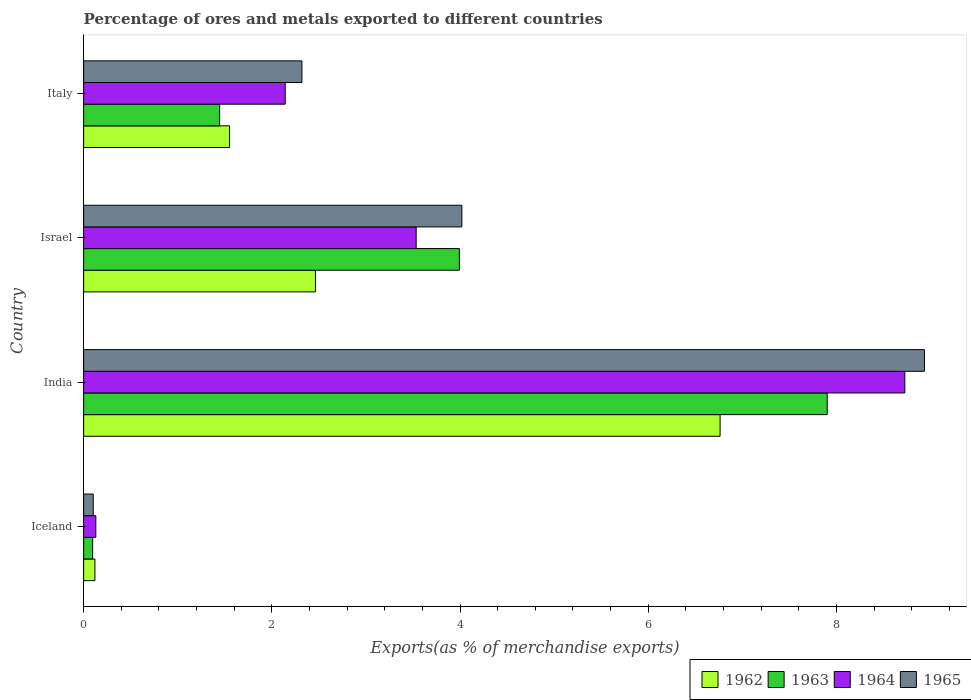How many groups of bars are there?
Your answer should be very brief. 4. Are the number of bars on each tick of the Y-axis equal?
Your response must be concise. Yes. How many bars are there on the 2nd tick from the bottom?
Your answer should be very brief. 4. What is the percentage of exports to different countries in 1963 in India?
Your answer should be compact. 7.9. Across all countries, what is the maximum percentage of exports to different countries in 1964?
Provide a succinct answer. 8.73. Across all countries, what is the minimum percentage of exports to different countries in 1963?
Ensure brevity in your answer.  0.1. In which country was the percentage of exports to different countries in 1965 maximum?
Offer a terse response. India. In which country was the percentage of exports to different countries in 1962 minimum?
Provide a succinct answer. Iceland. What is the total percentage of exports to different countries in 1964 in the graph?
Ensure brevity in your answer.  14.53. What is the difference between the percentage of exports to different countries in 1962 in Iceland and that in India?
Offer a very short reply. -6.64. What is the difference between the percentage of exports to different countries in 1964 in Iceland and the percentage of exports to different countries in 1963 in Israel?
Your answer should be compact. -3.86. What is the average percentage of exports to different countries in 1964 per country?
Offer a very short reply. 3.63. What is the difference between the percentage of exports to different countries in 1962 and percentage of exports to different countries in 1964 in India?
Offer a very short reply. -1.96. In how many countries, is the percentage of exports to different countries in 1965 greater than 4 %?
Ensure brevity in your answer.  2. What is the ratio of the percentage of exports to different countries in 1965 in Iceland to that in Israel?
Provide a succinct answer. 0.03. Is the percentage of exports to different countries in 1964 in Iceland less than that in India?
Provide a short and direct response. Yes. Is the difference between the percentage of exports to different countries in 1962 in India and Italy greater than the difference between the percentage of exports to different countries in 1964 in India and Italy?
Offer a terse response. No. What is the difference between the highest and the second highest percentage of exports to different countries in 1964?
Give a very brief answer. 5.19. What is the difference between the highest and the lowest percentage of exports to different countries in 1963?
Provide a succinct answer. 7.81. In how many countries, is the percentage of exports to different countries in 1963 greater than the average percentage of exports to different countries in 1963 taken over all countries?
Keep it short and to the point. 2. What does the 1st bar from the top in India represents?
Give a very brief answer. 1965. Are all the bars in the graph horizontal?
Make the answer very short. Yes. Are the values on the major ticks of X-axis written in scientific E-notation?
Your response must be concise. No. Does the graph contain grids?
Your answer should be very brief. No. How are the legend labels stacked?
Make the answer very short. Horizontal. What is the title of the graph?
Provide a short and direct response. Percentage of ores and metals exported to different countries. What is the label or title of the X-axis?
Provide a succinct answer. Exports(as % of merchandise exports). What is the label or title of the Y-axis?
Provide a succinct answer. Country. What is the Exports(as % of merchandise exports) in 1962 in Iceland?
Offer a terse response. 0.12. What is the Exports(as % of merchandise exports) of 1963 in Iceland?
Provide a short and direct response. 0.1. What is the Exports(as % of merchandise exports) of 1964 in Iceland?
Provide a short and direct response. 0.13. What is the Exports(as % of merchandise exports) of 1965 in Iceland?
Your response must be concise. 0.1. What is the Exports(as % of merchandise exports) of 1962 in India?
Provide a short and direct response. 6.76. What is the Exports(as % of merchandise exports) of 1963 in India?
Keep it short and to the point. 7.9. What is the Exports(as % of merchandise exports) in 1964 in India?
Offer a terse response. 8.73. What is the Exports(as % of merchandise exports) in 1965 in India?
Your response must be concise. 8.94. What is the Exports(as % of merchandise exports) of 1962 in Israel?
Make the answer very short. 2.46. What is the Exports(as % of merchandise exports) in 1963 in Israel?
Provide a succinct answer. 3.99. What is the Exports(as % of merchandise exports) in 1964 in Israel?
Give a very brief answer. 3.53. What is the Exports(as % of merchandise exports) of 1965 in Israel?
Provide a succinct answer. 4.02. What is the Exports(as % of merchandise exports) in 1962 in Italy?
Give a very brief answer. 1.55. What is the Exports(as % of merchandise exports) in 1963 in Italy?
Provide a succinct answer. 1.45. What is the Exports(as % of merchandise exports) in 1964 in Italy?
Your answer should be very brief. 2.14. What is the Exports(as % of merchandise exports) in 1965 in Italy?
Your answer should be compact. 2.32. Across all countries, what is the maximum Exports(as % of merchandise exports) in 1962?
Offer a very short reply. 6.76. Across all countries, what is the maximum Exports(as % of merchandise exports) in 1963?
Offer a terse response. 7.9. Across all countries, what is the maximum Exports(as % of merchandise exports) of 1964?
Your answer should be very brief. 8.73. Across all countries, what is the maximum Exports(as % of merchandise exports) in 1965?
Give a very brief answer. 8.94. Across all countries, what is the minimum Exports(as % of merchandise exports) of 1962?
Offer a terse response. 0.12. Across all countries, what is the minimum Exports(as % of merchandise exports) in 1963?
Offer a terse response. 0.1. Across all countries, what is the minimum Exports(as % of merchandise exports) in 1964?
Your answer should be very brief. 0.13. Across all countries, what is the minimum Exports(as % of merchandise exports) in 1965?
Provide a succinct answer. 0.1. What is the total Exports(as % of merchandise exports) of 1962 in the graph?
Provide a succinct answer. 10.9. What is the total Exports(as % of merchandise exports) in 1963 in the graph?
Keep it short and to the point. 13.44. What is the total Exports(as % of merchandise exports) of 1964 in the graph?
Keep it short and to the point. 14.53. What is the total Exports(as % of merchandise exports) in 1965 in the graph?
Give a very brief answer. 15.38. What is the difference between the Exports(as % of merchandise exports) in 1962 in Iceland and that in India?
Provide a succinct answer. -6.64. What is the difference between the Exports(as % of merchandise exports) in 1963 in Iceland and that in India?
Your answer should be compact. -7.81. What is the difference between the Exports(as % of merchandise exports) of 1964 in Iceland and that in India?
Your answer should be very brief. -8.6. What is the difference between the Exports(as % of merchandise exports) of 1965 in Iceland and that in India?
Your answer should be compact. -8.83. What is the difference between the Exports(as % of merchandise exports) of 1962 in Iceland and that in Israel?
Your answer should be compact. -2.34. What is the difference between the Exports(as % of merchandise exports) in 1963 in Iceland and that in Israel?
Your response must be concise. -3.9. What is the difference between the Exports(as % of merchandise exports) of 1964 in Iceland and that in Israel?
Offer a very short reply. -3.4. What is the difference between the Exports(as % of merchandise exports) in 1965 in Iceland and that in Israel?
Make the answer very short. -3.92. What is the difference between the Exports(as % of merchandise exports) in 1962 in Iceland and that in Italy?
Ensure brevity in your answer.  -1.43. What is the difference between the Exports(as % of merchandise exports) in 1963 in Iceland and that in Italy?
Provide a short and direct response. -1.35. What is the difference between the Exports(as % of merchandise exports) in 1964 in Iceland and that in Italy?
Your response must be concise. -2.01. What is the difference between the Exports(as % of merchandise exports) in 1965 in Iceland and that in Italy?
Your answer should be compact. -2.22. What is the difference between the Exports(as % of merchandise exports) in 1962 in India and that in Israel?
Provide a succinct answer. 4.3. What is the difference between the Exports(as % of merchandise exports) of 1963 in India and that in Israel?
Give a very brief answer. 3.91. What is the difference between the Exports(as % of merchandise exports) in 1964 in India and that in Israel?
Ensure brevity in your answer.  5.19. What is the difference between the Exports(as % of merchandise exports) in 1965 in India and that in Israel?
Offer a terse response. 4.92. What is the difference between the Exports(as % of merchandise exports) of 1962 in India and that in Italy?
Keep it short and to the point. 5.21. What is the difference between the Exports(as % of merchandise exports) in 1963 in India and that in Italy?
Make the answer very short. 6.46. What is the difference between the Exports(as % of merchandise exports) in 1964 in India and that in Italy?
Your response must be concise. 6.58. What is the difference between the Exports(as % of merchandise exports) in 1965 in India and that in Italy?
Your answer should be compact. 6.62. What is the difference between the Exports(as % of merchandise exports) in 1963 in Israel and that in Italy?
Provide a succinct answer. 2.55. What is the difference between the Exports(as % of merchandise exports) in 1964 in Israel and that in Italy?
Give a very brief answer. 1.39. What is the difference between the Exports(as % of merchandise exports) in 1965 in Israel and that in Italy?
Keep it short and to the point. 1.7. What is the difference between the Exports(as % of merchandise exports) of 1962 in Iceland and the Exports(as % of merchandise exports) of 1963 in India?
Give a very brief answer. -7.78. What is the difference between the Exports(as % of merchandise exports) of 1962 in Iceland and the Exports(as % of merchandise exports) of 1964 in India?
Offer a very short reply. -8.61. What is the difference between the Exports(as % of merchandise exports) of 1962 in Iceland and the Exports(as % of merchandise exports) of 1965 in India?
Your response must be concise. -8.82. What is the difference between the Exports(as % of merchandise exports) of 1963 in Iceland and the Exports(as % of merchandise exports) of 1964 in India?
Your answer should be very brief. -8.63. What is the difference between the Exports(as % of merchandise exports) of 1963 in Iceland and the Exports(as % of merchandise exports) of 1965 in India?
Provide a short and direct response. -8.84. What is the difference between the Exports(as % of merchandise exports) in 1964 in Iceland and the Exports(as % of merchandise exports) in 1965 in India?
Provide a short and direct response. -8.81. What is the difference between the Exports(as % of merchandise exports) in 1962 in Iceland and the Exports(as % of merchandise exports) in 1963 in Israel?
Your answer should be very brief. -3.87. What is the difference between the Exports(as % of merchandise exports) in 1962 in Iceland and the Exports(as % of merchandise exports) in 1964 in Israel?
Keep it short and to the point. -3.41. What is the difference between the Exports(as % of merchandise exports) of 1962 in Iceland and the Exports(as % of merchandise exports) of 1965 in Israel?
Ensure brevity in your answer.  -3.9. What is the difference between the Exports(as % of merchandise exports) in 1963 in Iceland and the Exports(as % of merchandise exports) in 1964 in Israel?
Your answer should be compact. -3.44. What is the difference between the Exports(as % of merchandise exports) in 1963 in Iceland and the Exports(as % of merchandise exports) in 1965 in Israel?
Ensure brevity in your answer.  -3.92. What is the difference between the Exports(as % of merchandise exports) in 1964 in Iceland and the Exports(as % of merchandise exports) in 1965 in Israel?
Offer a terse response. -3.89. What is the difference between the Exports(as % of merchandise exports) of 1962 in Iceland and the Exports(as % of merchandise exports) of 1963 in Italy?
Offer a terse response. -1.33. What is the difference between the Exports(as % of merchandise exports) of 1962 in Iceland and the Exports(as % of merchandise exports) of 1964 in Italy?
Give a very brief answer. -2.02. What is the difference between the Exports(as % of merchandise exports) of 1962 in Iceland and the Exports(as % of merchandise exports) of 1965 in Italy?
Offer a terse response. -2.2. What is the difference between the Exports(as % of merchandise exports) in 1963 in Iceland and the Exports(as % of merchandise exports) in 1964 in Italy?
Keep it short and to the point. -2.05. What is the difference between the Exports(as % of merchandise exports) in 1963 in Iceland and the Exports(as % of merchandise exports) in 1965 in Italy?
Offer a very short reply. -2.22. What is the difference between the Exports(as % of merchandise exports) in 1964 in Iceland and the Exports(as % of merchandise exports) in 1965 in Italy?
Ensure brevity in your answer.  -2.19. What is the difference between the Exports(as % of merchandise exports) of 1962 in India and the Exports(as % of merchandise exports) of 1963 in Israel?
Your response must be concise. 2.77. What is the difference between the Exports(as % of merchandise exports) in 1962 in India and the Exports(as % of merchandise exports) in 1964 in Israel?
Offer a very short reply. 3.23. What is the difference between the Exports(as % of merchandise exports) in 1962 in India and the Exports(as % of merchandise exports) in 1965 in Israel?
Your response must be concise. 2.74. What is the difference between the Exports(as % of merchandise exports) of 1963 in India and the Exports(as % of merchandise exports) of 1964 in Israel?
Keep it short and to the point. 4.37. What is the difference between the Exports(as % of merchandise exports) of 1963 in India and the Exports(as % of merchandise exports) of 1965 in Israel?
Offer a terse response. 3.88. What is the difference between the Exports(as % of merchandise exports) of 1964 in India and the Exports(as % of merchandise exports) of 1965 in Israel?
Provide a succinct answer. 4.71. What is the difference between the Exports(as % of merchandise exports) in 1962 in India and the Exports(as % of merchandise exports) in 1963 in Italy?
Provide a succinct answer. 5.32. What is the difference between the Exports(as % of merchandise exports) of 1962 in India and the Exports(as % of merchandise exports) of 1964 in Italy?
Give a very brief answer. 4.62. What is the difference between the Exports(as % of merchandise exports) in 1962 in India and the Exports(as % of merchandise exports) in 1965 in Italy?
Keep it short and to the point. 4.44. What is the difference between the Exports(as % of merchandise exports) of 1963 in India and the Exports(as % of merchandise exports) of 1964 in Italy?
Keep it short and to the point. 5.76. What is the difference between the Exports(as % of merchandise exports) of 1963 in India and the Exports(as % of merchandise exports) of 1965 in Italy?
Provide a succinct answer. 5.58. What is the difference between the Exports(as % of merchandise exports) of 1964 in India and the Exports(as % of merchandise exports) of 1965 in Italy?
Keep it short and to the point. 6.41. What is the difference between the Exports(as % of merchandise exports) in 1962 in Israel and the Exports(as % of merchandise exports) in 1963 in Italy?
Your response must be concise. 1.02. What is the difference between the Exports(as % of merchandise exports) in 1962 in Israel and the Exports(as % of merchandise exports) in 1964 in Italy?
Ensure brevity in your answer.  0.32. What is the difference between the Exports(as % of merchandise exports) in 1962 in Israel and the Exports(as % of merchandise exports) in 1965 in Italy?
Offer a very short reply. 0.14. What is the difference between the Exports(as % of merchandise exports) of 1963 in Israel and the Exports(as % of merchandise exports) of 1964 in Italy?
Provide a succinct answer. 1.85. What is the difference between the Exports(as % of merchandise exports) of 1963 in Israel and the Exports(as % of merchandise exports) of 1965 in Italy?
Your answer should be very brief. 1.67. What is the difference between the Exports(as % of merchandise exports) in 1964 in Israel and the Exports(as % of merchandise exports) in 1965 in Italy?
Offer a very short reply. 1.21. What is the average Exports(as % of merchandise exports) in 1962 per country?
Make the answer very short. 2.72. What is the average Exports(as % of merchandise exports) of 1963 per country?
Provide a succinct answer. 3.36. What is the average Exports(as % of merchandise exports) of 1964 per country?
Offer a terse response. 3.63. What is the average Exports(as % of merchandise exports) of 1965 per country?
Your answer should be very brief. 3.84. What is the difference between the Exports(as % of merchandise exports) in 1962 and Exports(as % of merchandise exports) in 1963 in Iceland?
Your answer should be very brief. 0.02. What is the difference between the Exports(as % of merchandise exports) in 1962 and Exports(as % of merchandise exports) in 1964 in Iceland?
Keep it short and to the point. -0.01. What is the difference between the Exports(as % of merchandise exports) of 1962 and Exports(as % of merchandise exports) of 1965 in Iceland?
Give a very brief answer. 0.02. What is the difference between the Exports(as % of merchandise exports) in 1963 and Exports(as % of merchandise exports) in 1964 in Iceland?
Offer a terse response. -0.03. What is the difference between the Exports(as % of merchandise exports) in 1963 and Exports(as % of merchandise exports) in 1965 in Iceland?
Give a very brief answer. -0.01. What is the difference between the Exports(as % of merchandise exports) of 1964 and Exports(as % of merchandise exports) of 1965 in Iceland?
Your response must be concise. 0.03. What is the difference between the Exports(as % of merchandise exports) in 1962 and Exports(as % of merchandise exports) in 1963 in India?
Your answer should be very brief. -1.14. What is the difference between the Exports(as % of merchandise exports) in 1962 and Exports(as % of merchandise exports) in 1964 in India?
Offer a very short reply. -1.96. What is the difference between the Exports(as % of merchandise exports) in 1962 and Exports(as % of merchandise exports) in 1965 in India?
Make the answer very short. -2.17. What is the difference between the Exports(as % of merchandise exports) in 1963 and Exports(as % of merchandise exports) in 1964 in India?
Offer a terse response. -0.82. What is the difference between the Exports(as % of merchandise exports) in 1963 and Exports(as % of merchandise exports) in 1965 in India?
Provide a short and direct response. -1.03. What is the difference between the Exports(as % of merchandise exports) in 1964 and Exports(as % of merchandise exports) in 1965 in India?
Keep it short and to the point. -0.21. What is the difference between the Exports(as % of merchandise exports) in 1962 and Exports(as % of merchandise exports) in 1963 in Israel?
Your answer should be compact. -1.53. What is the difference between the Exports(as % of merchandise exports) in 1962 and Exports(as % of merchandise exports) in 1964 in Israel?
Keep it short and to the point. -1.07. What is the difference between the Exports(as % of merchandise exports) of 1962 and Exports(as % of merchandise exports) of 1965 in Israel?
Your answer should be compact. -1.56. What is the difference between the Exports(as % of merchandise exports) of 1963 and Exports(as % of merchandise exports) of 1964 in Israel?
Provide a succinct answer. 0.46. What is the difference between the Exports(as % of merchandise exports) of 1963 and Exports(as % of merchandise exports) of 1965 in Israel?
Ensure brevity in your answer.  -0.03. What is the difference between the Exports(as % of merchandise exports) of 1964 and Exports(as % of merchandise exports) of 1965 in Israel?
Provide a short and direct response. -0.49. What is the difference between the Exports(as % of merchandise exports) of 1962 and Exports(as % of merchandise exports) of 1963 in Italy?
Provide a short and direct response. 0.11. What is the difference between the Exports(as % of merchandise exports) of 1962 and Exports(as % of merchandise exports) of 1964 in Italy?
Offer a very short reply. -0.59. What is the difference between the Exports(as % of merchandise exports) in 1962 and Exports(as % of merchandise exports) in 1965 in Italy?
Ensure brevity in your answer.  -0.77. What is the difference between the Exports(as % of merchandise exports) in 1963 and Exports(as % of merchandise exports) in 1964 in Italy?
Give a very brief answer. -0.7. What is the difference between the Exports(as % of merchandise exports) in 1963 and Exports(as % of merchandise exports) in 1965 in Italy?
Your answer should be compact. -0.87. What is the difference between the Exports(as % of merchandise exports) of 1964 and Exports(as % of merchandise exports) of 1965 in Italy?
Your answer should be very brief. -0.18. What is the ratio of the Exports(as % of merchandise exports) in 1962 in Iceland to that in India?
Give a very brief answer. 0.02. What is the ratio of the Exports(as % of merchandise exports) in 1963 in Iceland to that in India?
Ensure brevity in your answer.  0.01. What is the ratio of the Exports(as % of merchandise exports) of 1964 in Iceland to that in India?
Your response must be concise. 0.01. What is the ratio of the Exports(as % of merchandise exports) of 1965 in Iceland to that in India?
Keep it short and to the point. 0.01. What is the ratio of the Exports(as % of merchandise exports) of 1962 in Iceland to that in Israel?
Provide a short and direct response. 0.05. What is the ratio of the Exports(as % of merchandise exports) in 1963 in Iceland to that in Israel?
Offer a terse response. 0.02. What is the ratio of the Exports(as % of merchandise exports) of 1964 in Iceland to that in Israel?
Ensure brevity in your answer.  0.04. What is the ratio of the Exports(as % of merchandise exports) of 1965 in Iceland to that in Israel?
Keep it short and to the point. 0.03. What is the ratio of the Exports(as % of merchandise exports) of 1962 in Iceland to that in Italy?
Make the answer very short. 0.08. What is the ratio of the Exports(as % of merchandise exports) of 1963 in Iceland to that in Italy?
Your response must be concise. 0.07. What is the ratio of the Exports(as % of merchandise exports) of 1964 in Iceland to that in Italy?
Your answer should be very brief. 0.06. What is the ratio of the Exports(as % of merchandise exports) of 1965 in Iceland to that in Italy?
Your response must be concise. 0.04. What is the ratio of the Exports(as % of merchandise exports) in 1962 in India to that in Israel?
Offer a terse response. 2.75. What is the ratio of the Exports(as % of merchandise exports) of 1963 in India to that in Israel?
Your response must be concise. 1.98. What is the ratio of the Exports(as % of merchandise exports) in 1964 in India to that in Israel?
Offer a terse response. 2.47. What is the ratio of the Exports(as % of merchandise exports) in 1965 in India to that in Israel?
Ensure brevity in your answer.  2.22. What is the ratio of the Exports(as % of merchandise exports) of 1962 in India to that in Italy?
Your answer should be compact. 4.36. What is the ratio of the Exports(as % of merchandise exports) in 1963 in India to that in Italy?
Keep it short and to the point. 5.47. What is the ratio of the Exports(as % of merchandise exports) of 1964 in India to that in Italy?
Provide a short and direct response. 4.07. What is the ratio of the Exports(as % of merchandise exports) of 1965 in India to that in Italy?
Give a very brief answer. 3.85. What is the ratio of the Exports(as % of merchandise exports) in 1962 in Israel to that in Italy?
Your answer should be very brief. 1.59. What is the ratio of the Exports(as % of merchandise exports) in 1963 in Israel to that in Italy?
Provide a short and direct response. 2.76. What is the ratio of the Exports(as % of merchandise exports) in 1964 in Israel to that in Italy?
Offer a very short reply. 1.65. What is the ratio of the Exports(as % of merchandise exports) of 1965 in Israel to that in Italy?
Ensure brevity in your answer.  1.73. What is the difference between the highest and the second highest Exports(as % of merchandise exports) in 1962?
Offer a terse response. 4.3. What is the difference between the highest and the second highest Exports(as % of merchandise exports) in 1963?
Provide a succinct answer. 3.91. What is the difference between the highest and the second highest Exports(as % of merchandise exports) of 1964?
Provide a short and direct response. 5.19. What is the difference between the highest and the second highest Exports(as % of merchandise exports) of 1965?
Your response must be concise. 4.92. What is the difference between the highest and the lowest Exports(as % of merchandise exports) of 1962?
Provide a succinct answer. 6.64. What is the difference between the highest and the lowest Exports(as % of merchandise exports) of 1963?
Keep it short and to the point. 7.81. What is the difference between the highest and the lowest Exports(as % of merchandise exports) in 1964?
Make the answer very short. 8.6. What is the difference between the highest and the lowest Exports(as % of merchandise exports) of 1965?
Your answer should be very brief. 8.83. 